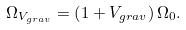Convert formula to latex. <formula><loc_0><loc_0><loc_500><loc_500>\Omega _ { V _ { g r a v } } = \left ( 1 + V _ { g r a v } \right ) \Omega _ { 0 } .</formula> 